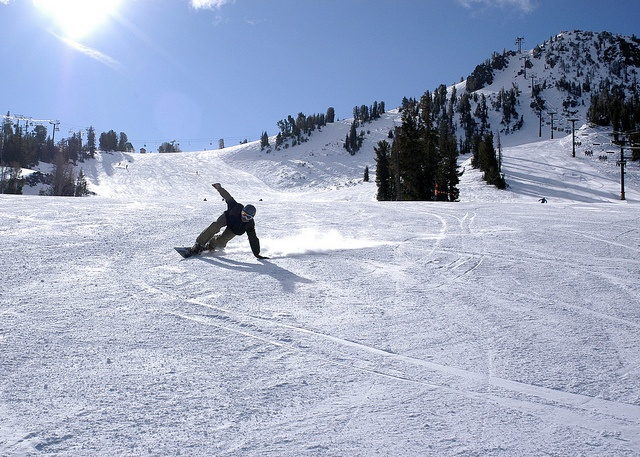Describe the objects in this image and their specific colors. I can see people in lavender, black, gray, and lightgray tones and snowboard in lavender, black, gray, and darkblue tones in this image. 